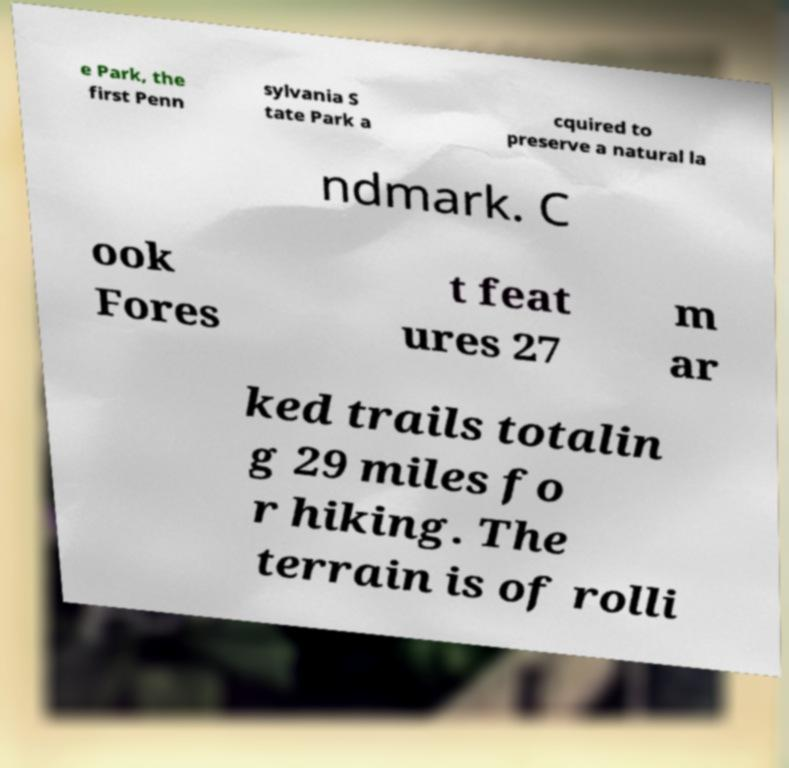I need the written content from this picture converted into text. Can you do that? e Park, the first Penn sylvania S tate Park a cquired to preserve a natural la ndmark. C ook Fores t feat ures 27 m ar ked trails totalin g 29 miles fo r hiking. The terrain is of rolli 